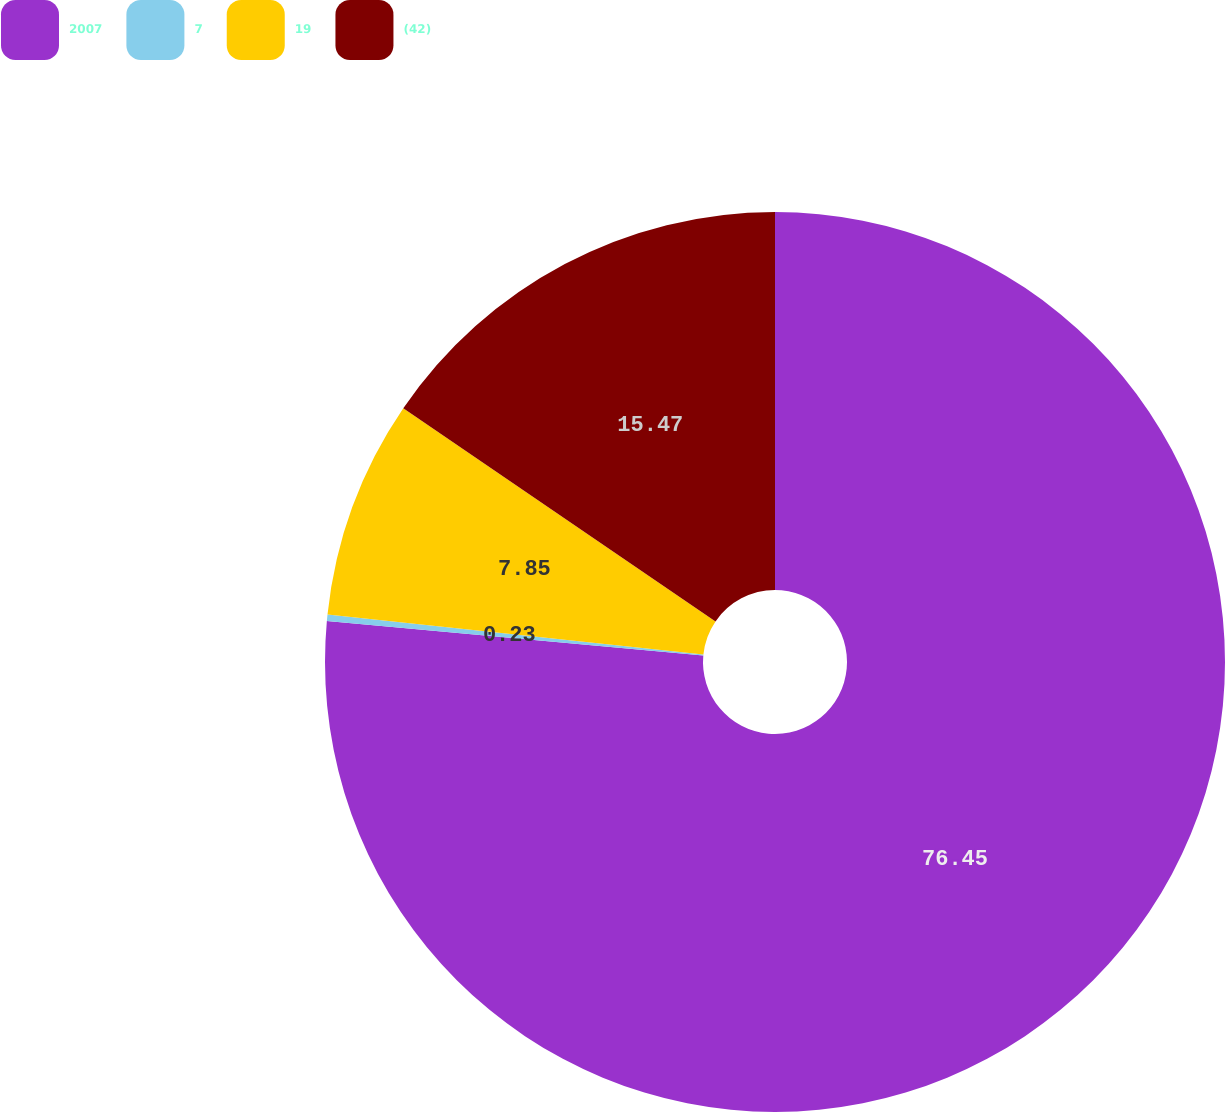Convert chart to OTSL. <chart><loc_0><loc_0><loc_500><loc_500><pie_chart><fcel>2007<fcel>7<fcel>19<fcel>(42)<nl><fcel>76.45%<fcel>0.23%<fcel>7.85%<fcel>15.47%<nl></chart> 